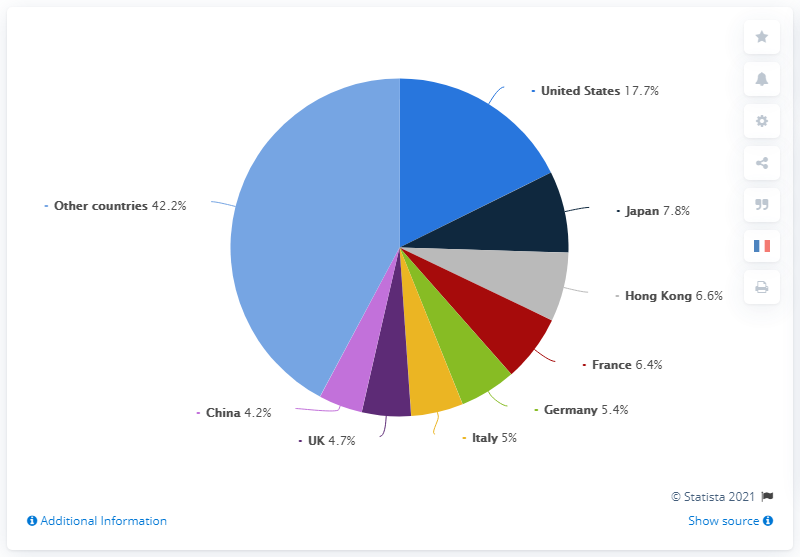Indicate a few pertinent items in this graphic. The United States and other countries together produced leather goods imports that exceeded 50% of the overall imports. The light purple colored segment is the smallest. 